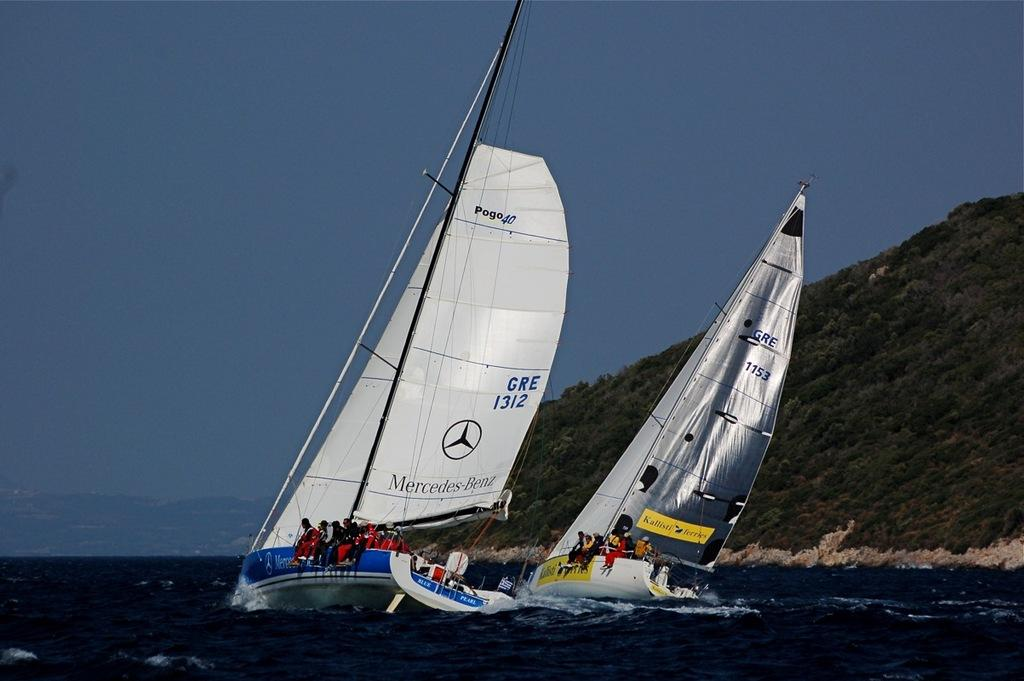<image>
Present a compact description of the photo's key features. A boat with a sail that says Mercedez Benz on it. 